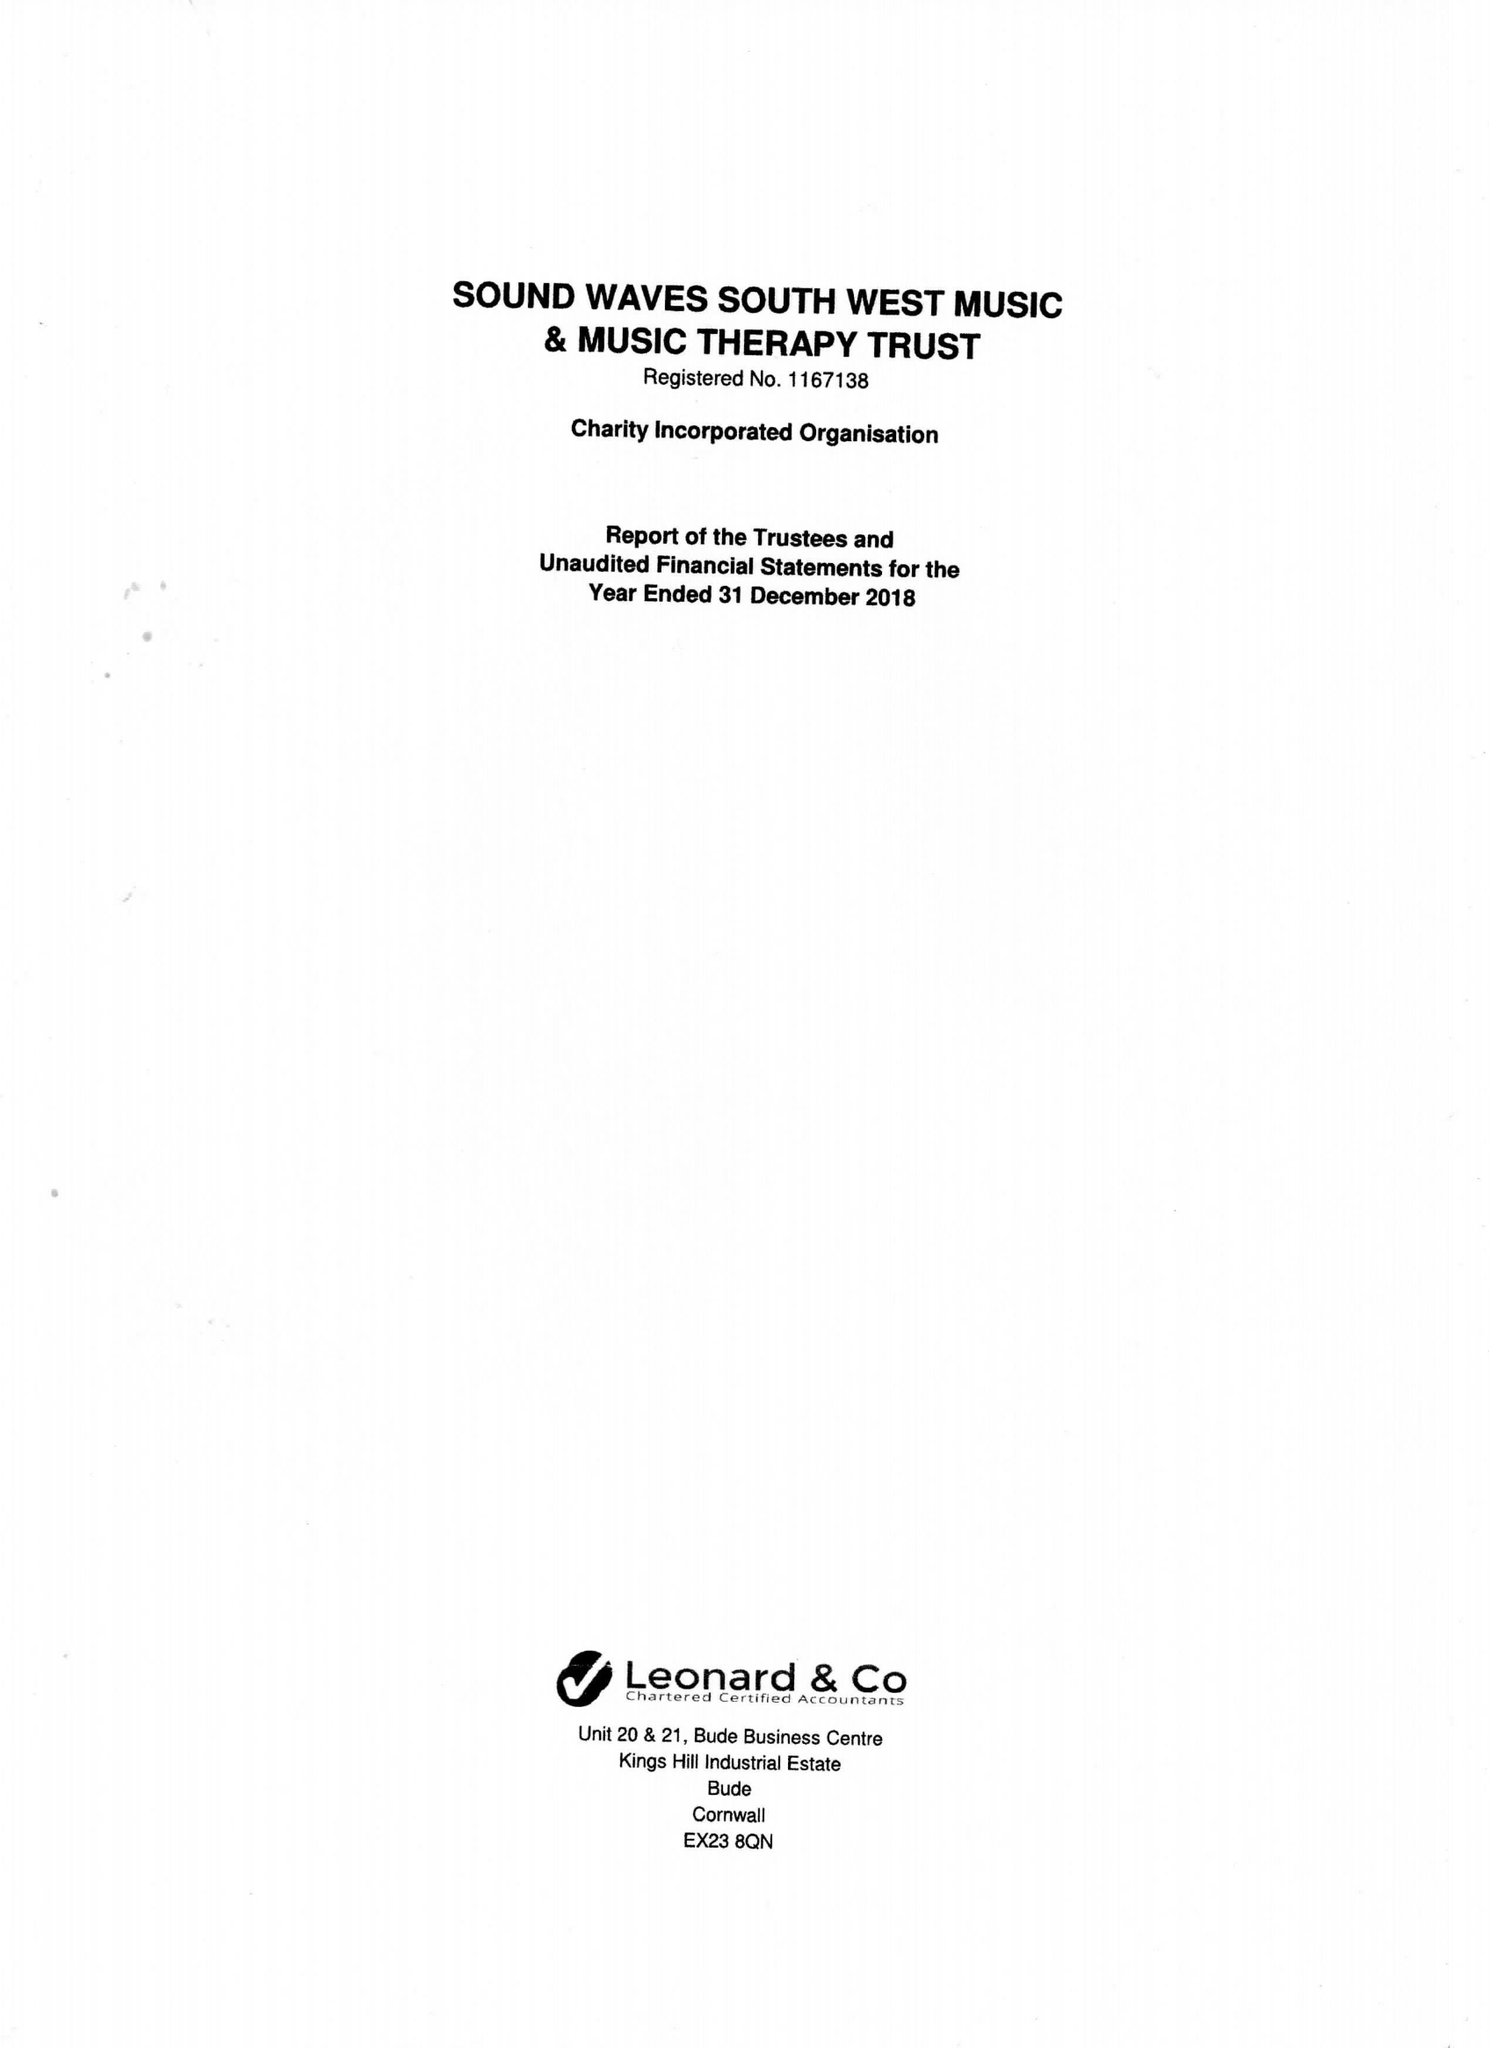What is the value for the address__street_line?
Answer the question using a single word or phrase. WOODFORD 